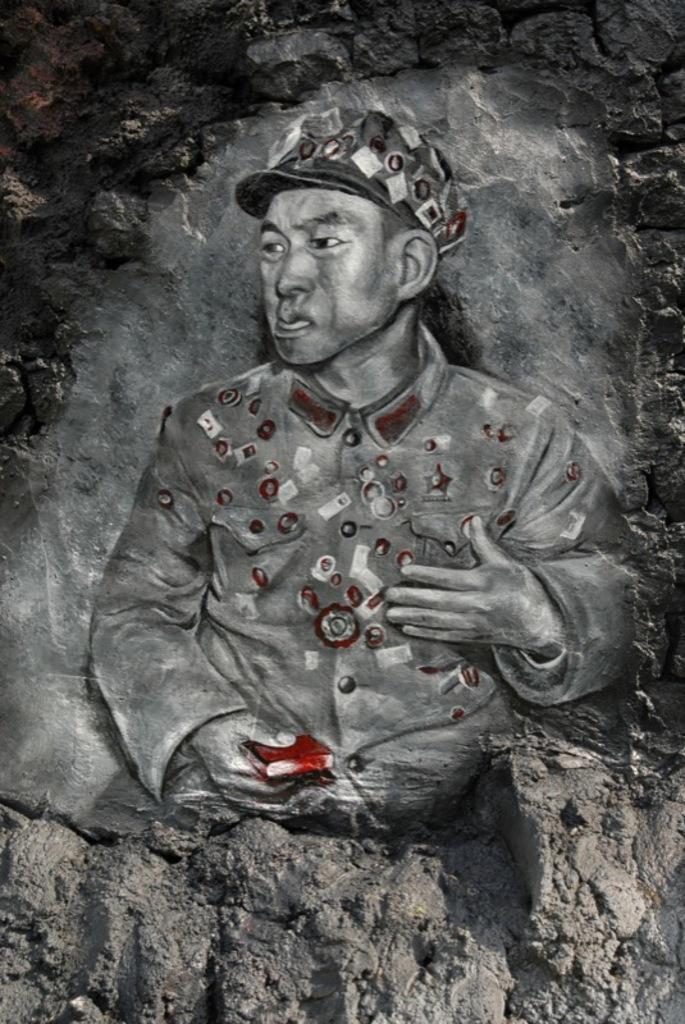How would you summarize this image in a sentence or two? In this image there is a painting of a person engraved on a stone. 